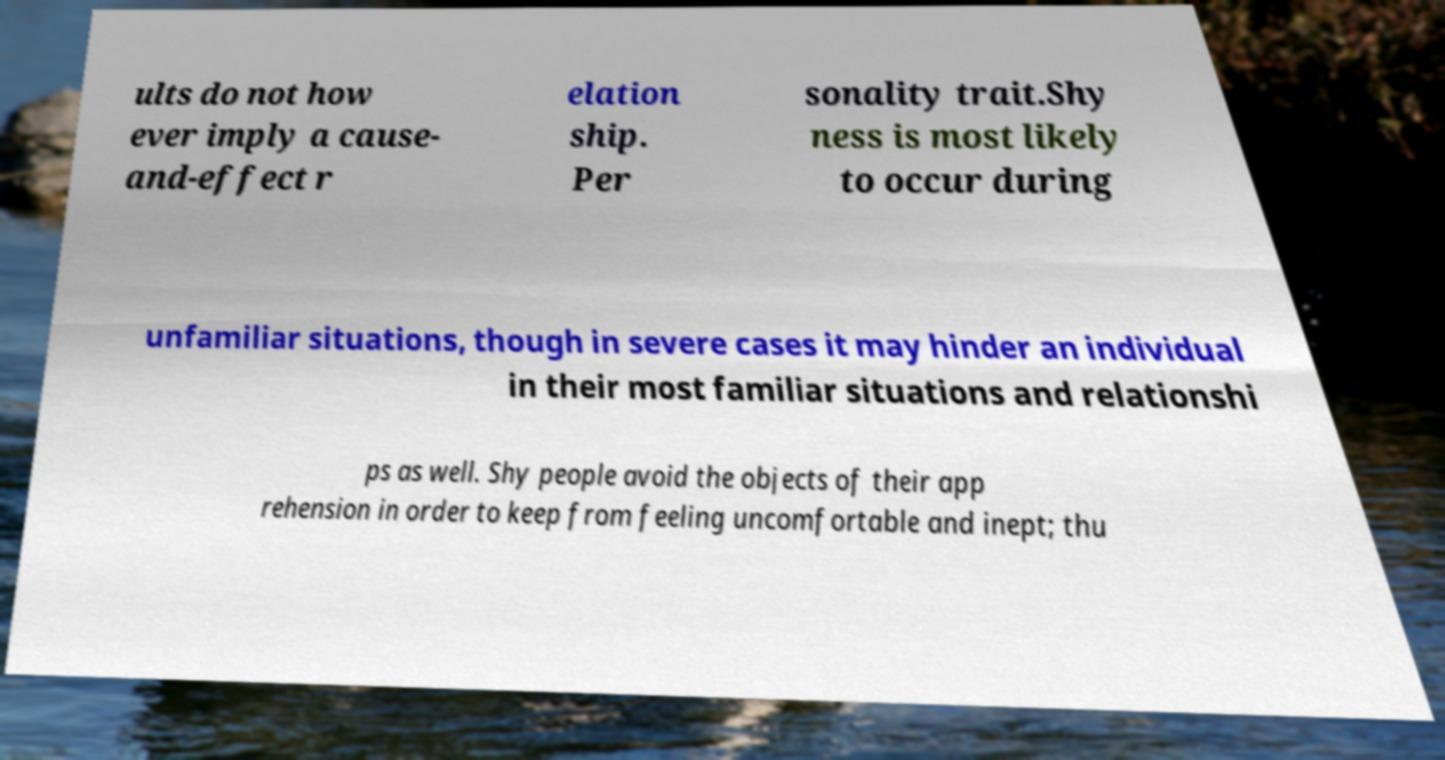Could you assist in decoding the text presented in this image and type it out clearly? ults do not how ever imply a cause- and-effect r elation ship. Per sonality trait.Shy ness is most likely to occur during unfamiliar situations, though in severe cases it may hinder an individual in their most familiar situations and relationshi ps as well. Shy people avoid the objects of their app rehension in order to keep from feeling uncomfortable and inept; thu 